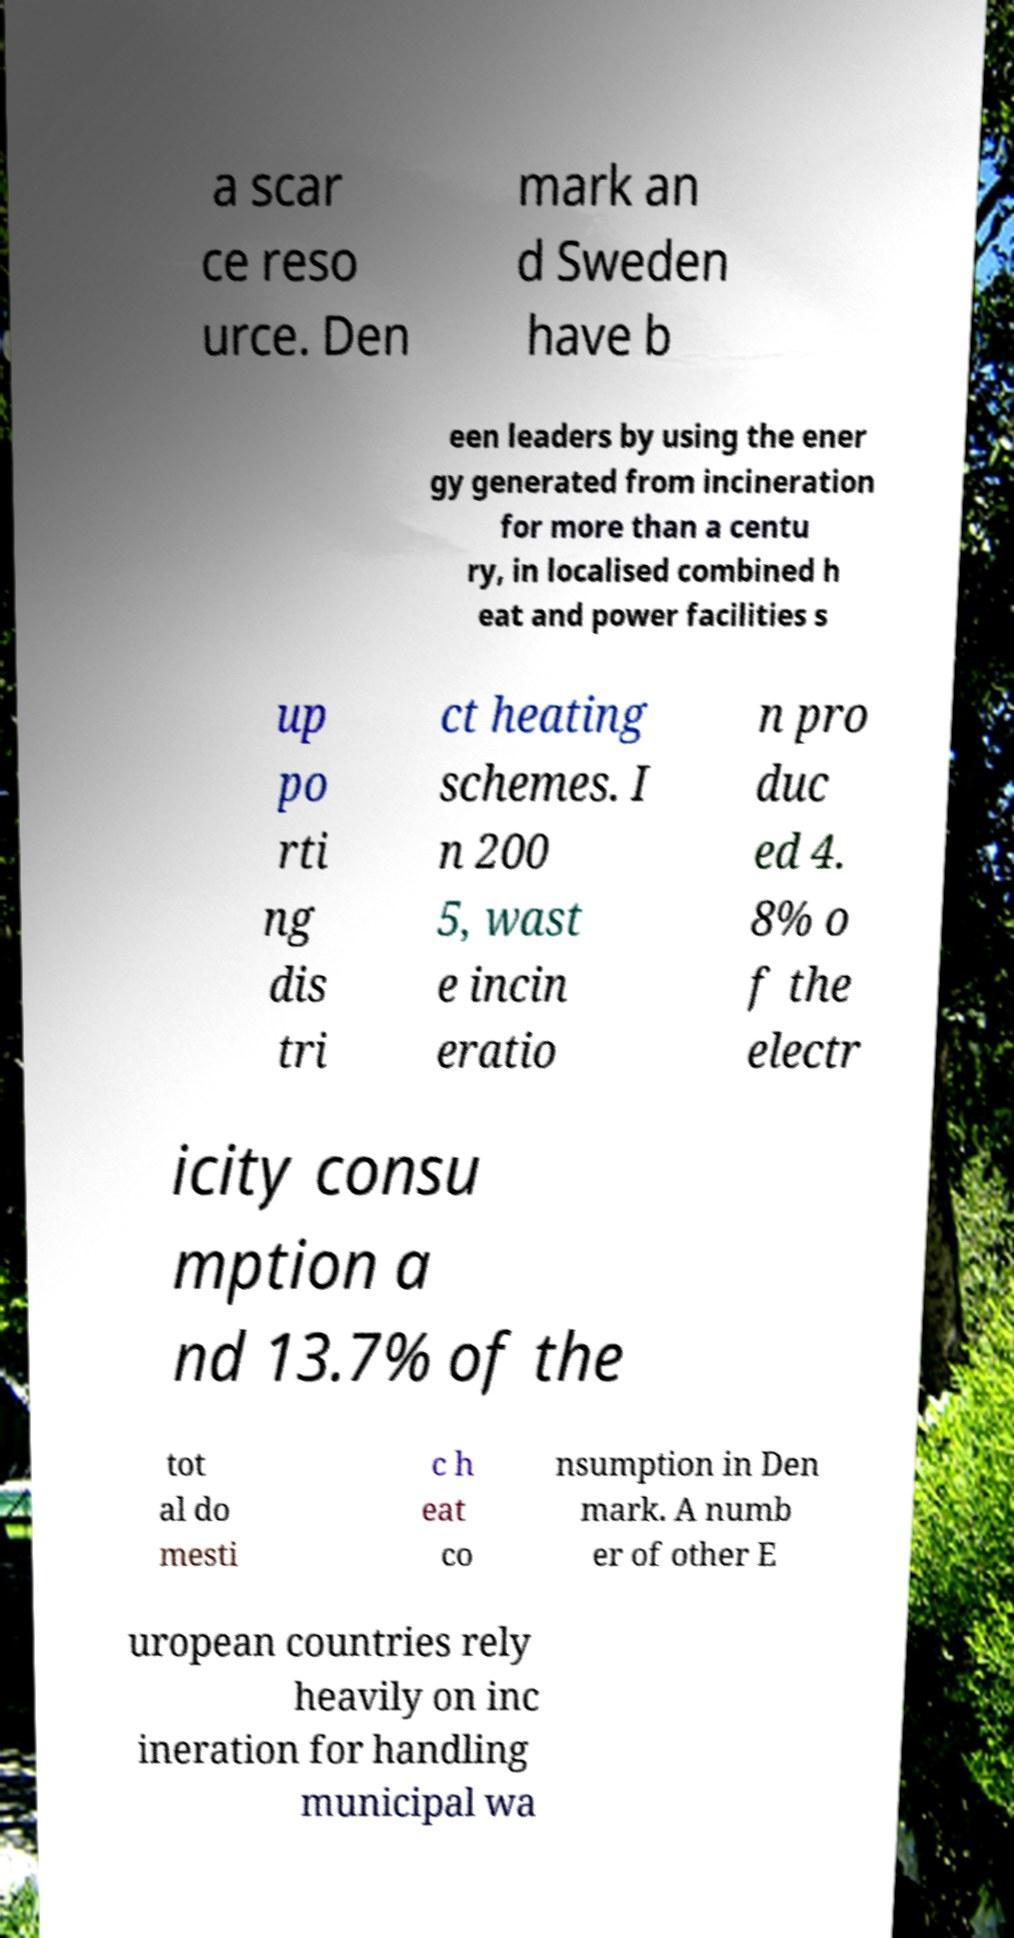There's text embedded in this image that I need extracted. Can you transcribe it verbatim? a scar ce reso urce. Den mark an d Sweden have b een leaders by using the ener gy generated from incineration for more than a centu ry, in localised combined h eat and power facilities s up po rti ng dis tri ct heating schemes. I n 200 5, wast e incin eratio n pro duc ed 4. 8% o f the electr icity consu mption a nd 13.7% of the tot al do mesti c h eat co nsumption in Den mark. A numb er of other E uropean countries rely heavily on inc ineration for handling municipal wa 